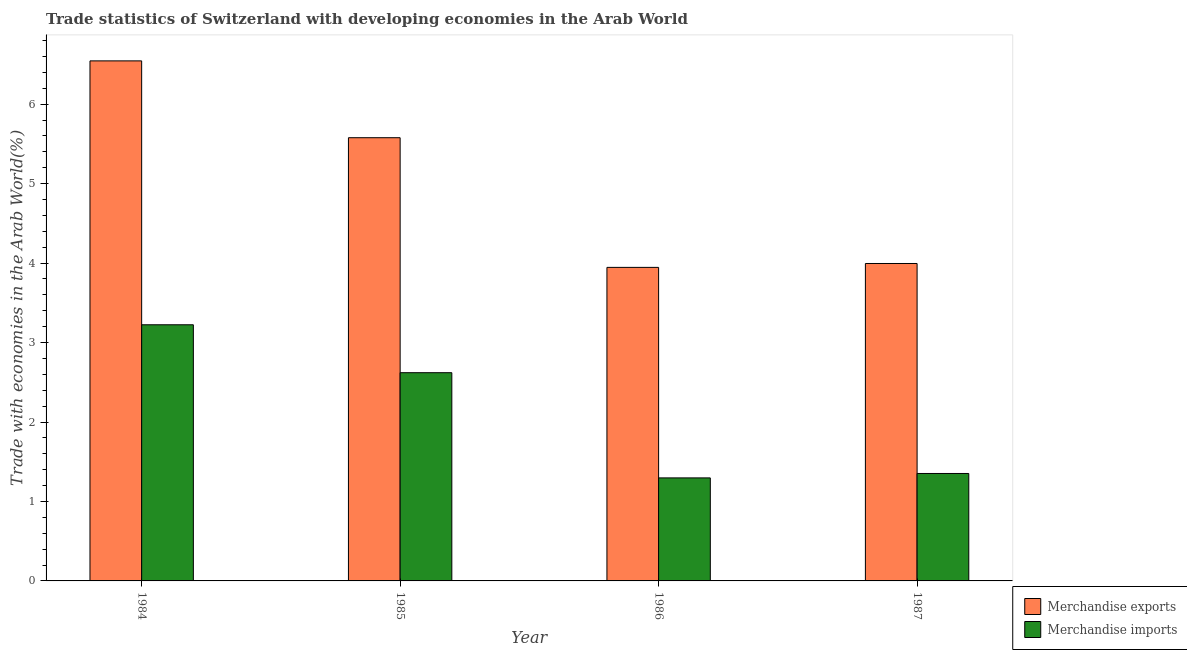How many bars are there on the 1st tick from the right?
Offer a terse response. 2. In how many cases, is the number of bars for a given year not equal to the number of legend labels?
Give a very brief answer. 0. What is the merchandise exports in 1985?
Your response must be concise. 5.58. Across all years, what is the maximum merchandise exports?
Provide a short and direct response. 6.54. Across all years, what is the minimum merchandise imports?
Give a very brief answer. 1.3. What is the total merchandise imports in the graph?
Ensure brevity in your answer.  8.49. What is the difference between the merchandise imports in 1984 and that in 1985?
Provide a succinct answer. 0.6. What is the difference between the merchandise exports in 1986 and the merchandise imports in 1987?
Offer a terse response. -0.05. What is the average merchandise exports per year?
Your response must be concise. 5.02. What is the ratio of the merchandise exports in 1984 to that in 1986?
Your response must be concise. 1.66. Is the merchandise imports in 1985 less than that in 1986?
Provide a short and direct response. No. Is the difference between the merchandise exports in 1985 and 1986 greater than the difference between the merchandise imports in 1985 and 1986?
Provide a succinct answer. No. What is the difference between the highest and the second highest merchandise exports?
Your answer should be compact. 0.97. What is the difference between the highest and the lowest merchandise exports?
Keep it short and to the point. 2.6. What does the 1st bar from the left in 1985 represents?
Your answer should be compact. Merchandise exports. How many bars are there?
Your response must be concise. 8. How many years are there in the graph?
Offer a very short reply. 4. Does the graph contain any zero values?
Your answer should be very brief. No. Does the graph contain grids?
Your answer should be very brief. No. How many legend labels are there?
Provide a short and direct response. 2. What is the title of the graph?
Make the answer very short. Trade statistics of Switzerland with developing economies in the Arab World. Does "Rural" appear as one of the legend labels in the graph?
Keep it short and to the point. No. What is the label or title of the Y-axis?
Offer a very short reply. Trade with economies in the Arab World(%). What is the Trade with economies in the Arab World(%) in Merchandise exports in 1984?
Your answer should be very brief. 6.54. What is the Trade with economies in the Arab World(%) in Merchandise imports in 1984?
Provide a succinct answer. 3.22. What is the Trade with economies in the Arab World(%) of Merchandise exports in 1985?
Provide a succinct answer. 5.58. What is the Trade with economies in the Arab World(%) in Merchandise imports in 1985?
Offer a terse response. 2.62. What is the Trade with economies in the Arab World(%) of Merchandise exports in 1986?
Make the answer very short. 3.95. What is the Trade with economies in the Arab World(%) of Merchandise imports in 1986?
Your response must be concise. 1.3. What is the Trade with economies in the Arab World(%) of Merchandise exports in 1987?
Your answer should be compact. 3.99. What is the Trade with economies in the Arab World(%) in Merchandise imports in 1987?
Your answer should be very brief. 1.35. Across all years, what is the maximum Trade with economies in the Arab World(%) of Merchandise exports?
Your response must be concise. 6.54. Across all years, what is the maximum Trade with economies in the Arab World(%) of Merchandise imports?
Keep it short and to the point. 3.22. Across all years, what is the minimum Trade with economies in the Arab World(%) of Merchandise exports?
Provide a succinct answer. 3.95. Across all years, what is the minimum Trade with economies in the Arab World(%) of Merchandise imports?
Make the answer very short. 1.3. What is the total Trade with economies in the Arab World(%) in Merchandise exports in the graph?
Your answer should be compact. 20.06. What is the total Trade with economies in the Arab World(%) in Merchandise imports in the graph?
Your response must be concise. 8.49. What is the difference between the Trade with economies in the Arab World(%) in Merchandise exports in 1984 and that in 1985?
Offer a very short reply. 0.97. What is the difference between the Trade with economies in the Arab World(%) of Merchandise imports in 1984 and that in 1985?
Your answer should be compact. 0.6. What is the difference between the Trade with economies in the Arab World(%) of Merchandise exports in 1984 and that in 1986?
Your answer should be very brief. 2.6. What is the difference between the Trade with economies in the Arab World(%) in Merchandise imports in 1984 and that in 1986?
Your answer should be very brief. 1.93. What is the difference between the Trade with economies in the Arab World(%) in Merchandise exports in 1984 and that in 1987?
Keep it short and to the point. 2.55. What is the difference between the Trade with economies in the Arab World(%) in Merchandise imports in 1984 and that in 1987?
Keep it short and to the point. 1.87. What is the difference between the Trade with economies in the Arab World(%) in Merchandise exports in 1985 and that in 1986?
Offer a very short reply. 1.63. What is the difference between the Trade with economies in the Arab World(%) in Merchandise imports in 1985 and that in 1986?
Make the answer very short. 1.32. What is the difference between the Trade with economies in the Arab World(%) in Merchandise exports in 1985 and that in 1987?
Provide a short and direct response. 1.58. What is the difference between the Trade with economies in the Arab World(%) in Merchandise imports in 1985 and that in 1987?
Your answer should be compact. 1.27. What is the difference between the Trade with economies in the Arab World(%) of Merchandise exports in 1986 and that in 1987?
Keep it short and to the point. -0.05. What is the difference between the Trade with economies in the Arab World(%) in Merchandise imports in 1986 and that in 1987?
Provide a short and direct response. -0.06. What is the difference between the Trade with economies in the Arab World(%) of Merchandise exports in 1984 and the Trade with economies in the Arab World(%) of Merchandise imports in 1985?
Ensure brevity in your answer.  3.92. What is the difference between the Trade with economies in the Arab World(%) in Merchandise exports in 1984 and the Trade with economies in the Arab World(%) in Merchandise imports in 1986?
Offer a very short reply. 5.25. What is the difference between the Trade with economies in the Arab World(%) of Merchandise exports in 1984 and the Trade with economies in the Arab World(%) of Merchandise imports in 1987?
Your answer should be compact. 5.19. What is the difference between the Trade with economies in the Arab World(%) in Merchandise exports in 1985 and the Trade with economies in the Arab World(%) in Merchandise imports in 1986?
Your answer should be compact. 4.28. What is the difference between the Trade with economies in the Arab World(%) in Merchandise exports in 1985 and the Trade with economies in the Arab World(%) in Merchandise imports in 1987?
Provide a short and direct response. 4.23. What is the difference between the Trade with economies in the Arab World(%) of Merchandise exports in 1986 and the Trade with economies in the Arab World(%) of Merchandise imports in 1987?
Offer a very short reply. 2.59. What is the average Trade with economies in the Arab World(%) of Merchandise exports per year?
Your answer should be very brief. 5.02. What is the average Trade with economies in the Arab World(%) of Merchandise imports per year?
Ensure brevity in your answer.  2.12. In the year 1984, what is the difference between the Trade with economies in the Arab World(%) in Merchandise exports and Trade with economies in the Arab World(%) in Merchandise imports?
Give a very brief answer. 3.32. In the year 1985, what is the difference between the Trade with economies in the Arab World(%) in Merchandise exports and Trade with economies in the Arab World(%) in Merchandise imports?
Provide a short and direct response. 2.96. In the year 1986, what is the difference between the Trade with economies in the Arab World(%) in Merchandise exports and Trade with economies in the Arab World(%) in Merchandise imports?
Make the answer very short. 2.65. In the year 1987, what is the difference between the Trade with economies in the Arab World(%) in Merchandise exports and Trade with economies in the Arab World(%) in Merchandise imports?
Make the answer very short. 2.64. What is the ratio of the Trade with economies in the Arab World(%) in Merchandise exports in 1984 to that in 1985?
Keep it short and to the point. 1.17. What is the ratio of the Trade with economies in the Arab World(%) in Merchandise imports in 1984 to that in 1985?
Offer a very short reply. 1.23. What is the ratio of the Trade with economies in the Arab World(%) of Merchandise exports in 1984 to that in 1986?
Your answer should be compact. 1.66. What is the ratio of the Trade with economies in the Arab World(%) in Merchandise imports in 1984 to that in 1986?
Your answer should be compact. 2.49. What is the ratio of the Trade with economies in the Arab World(%) of Merchandise exports in 1984 to that in 1987?
Your response must be concise. 1.64. What is the ratio of the Trade with economies in the Arab World(%) of Merchandise imports in 1984 to that in 1987?
Your response must be concise. 2.38. What is the ratio of the Trade with economies in the Arab World(%) in Merchandise exports in 1985 to that in 1986?
Your answer should be compact. 1.41. What is the ratio of the Trade with economies in the Arab World(%) in Merchandise imports in 1985 to that in 1986?
Ensure brevity in your answer.  2.02. What is the ratio of the Trade with economies in the Arab World(%) in Merchandise exports in 1985 to that in 1987?
Your response must be concise. 1.4. What is the ratio of the Trade with economies in the Arab World(%) of Merchandise imports in 1985 to that in 1987?
Keep it short and to the point. 1.94. What is the ratio of the Trade with economies in the Arab World(%) of Merchandise exports in 1986 to that in 1987?
Your response must be concise. 0.99. What is the ratio of the Trade with economies in the Arab World(%) of Merchandise imports in 1986 to that in 1987?
Offer a very short reply. 0.96. What is the difference between the highest and the second highest Trade with economies in the Arab World(%) of Merchandise exports?
Make the answer very short. 0.97. What is the difference between the highest and the second highest Trade with economies in the Arab World(%) of Merchandise imports?
Give a very brief answer. 0.6. What is the difference between the highest and the lowest Trade with economies in the Arab World(%) of Merchandise exports?
Make the answer very short. 2.6. What is the difference between the highest and the lowest Trade with economies in the Arab World(%) in Merchandise imports?
Your answer should be very brief. 1.93. 